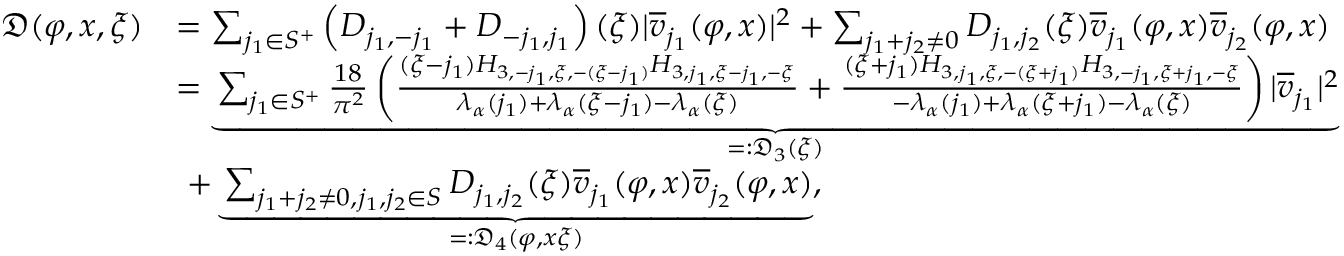<formula> <loc_0><loc_0><loc_500><loc_500>\begin{array} { r l } { \mathfrak { D } ( \varphi , x , \xi ) } & { = \sum _ { j _ { 1 } \in S ^ { + } } \left ( D _ { j _ { 1 } , - j _ { 1 } } + D _ { - j _ { 1 } , j _ { 1 } } \right ) ( \xi ) | \overline { v } _ { j _ { 1 } } ( \varphi , x ) | ^ { 2 } + \sum _ { j _ { 1 } + j _ { 2 } \ne 0 } D _ { j _ { 1 } , j _ { 2 } } ( \xi ) \overline { v } _ { j _ { 1 } } ( \varphi , x ) \overline { v } _ { j _ { 2 } } ( \varphi , x ) } \\ & { = \underbrace { \sum _ { j _ { 1 } \in S ^ { + } } \frac { 1 8 } { \pi ^ { 2 } } \left ( \frac { ( \xi - j _ { 1 } ) H _ { 3 , - j _ { 1 } , \xi , - ( \xi - j _ { 1 } ) } H _ { 3 , j _ { 1 } , \xi - j _ { 1 } , - \xi } } { \lambda _ { \alpha } ( j _ { 1 } ) + \lambda _ { \alpha } ( \xi - j _ { 1 } ) - \lambda _ { \alpha } ( \xi ) } + \frac { ( \xi + j _ { 1 } ) H _ { 3 , j _ { 1 } , \xi , - ( \xi + j _ { 1 } ) } H _ { 3 , - j _ { 1 } , \xi + j _ { 1 } , - \xi } } { - \lambda _ { \alpha } ( j _ { 1 } ) + \lambda _ { \alpha } ( \xi + j _ { 1 } ) - \lambda _ { \alpha } ( \xi ) } \right ) | \overline { v } _ { j _ { 1 } } | ^ { 2 } } _ { = \colon \mathfrak { D } _ { 3 } ( \xi ) } } \\ & { \ + \underbrace { \sum _ { j _ { 1 } + j _ { 2 } \ne 0 , j _ { 1 } , j _ { 2 } \in S } D _ { j _ { 1 } , j _ { 2 } } ( \xi ) \overline { v } _ { j _ { 1 } } ( \varphi , x ) \overline { v } _ { j _ { 2 } } ( \varphi , x ) } _ { = \colon \mathfrak { D } _ { 4 } ( \varphi , x \xi ) } , } \end{array}</formula> 